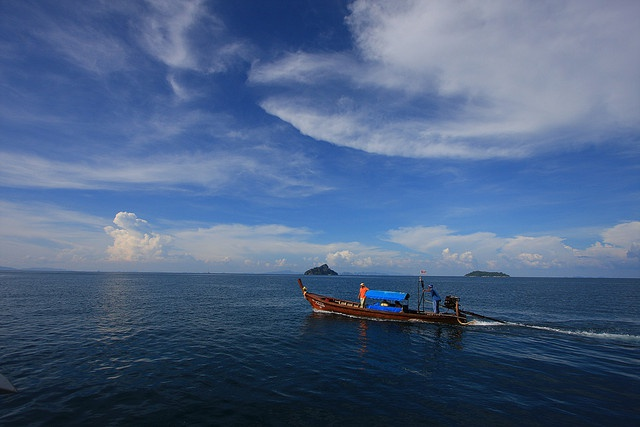Describe the objects in this image and their specific colors. I can see boat in darkblue, black, maroon, blue, and gray tones, people in darkblue, black, navy, blue, and gray tones, and people in darkblue, red, black, blue, and navy tones in this image. 